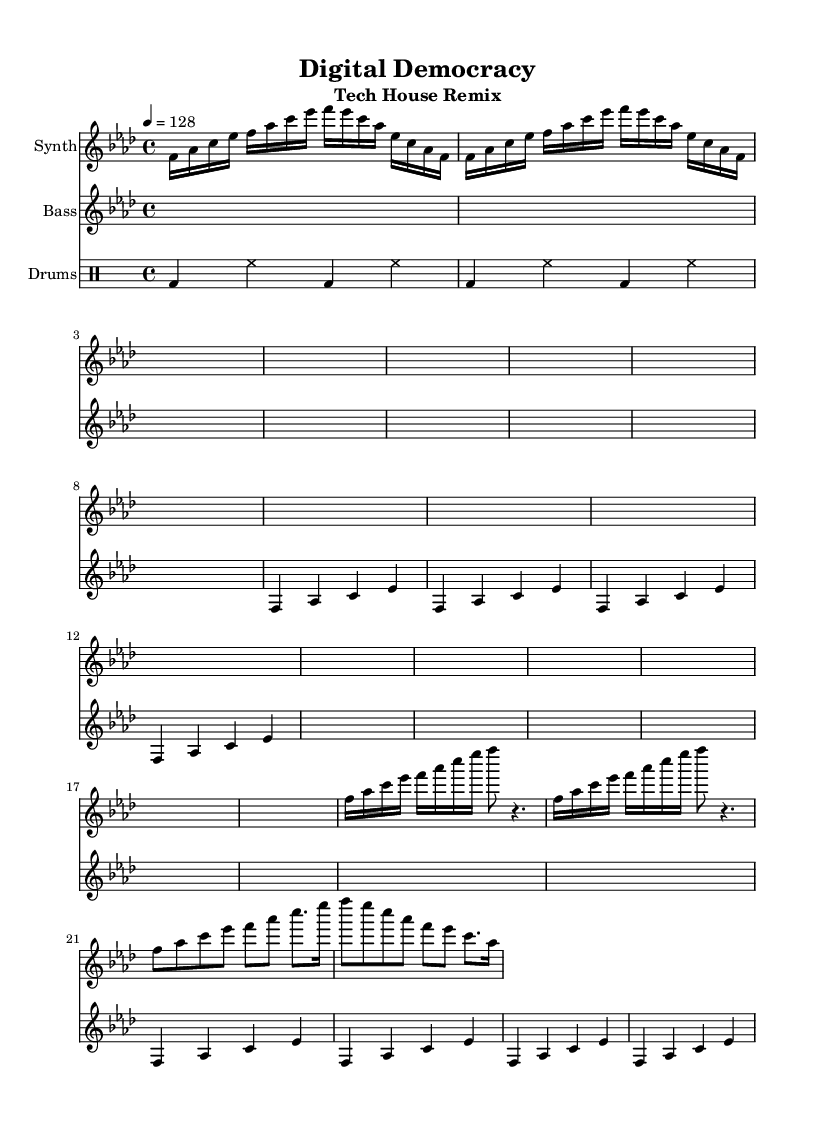What is the key signature of this music? The key signature is F minor, which is indicated by four flats (B♭, E♭, A♭, and D♭). This information is derived from the key signature notation at the beginning of the score.
Answer: F minor What is the time signature of this music? The time signature is 4/4, which is noted at the beginning of the score. This means there are four beats in a measure, and the quarter note gets one beat.
Answer: 4/4 What is the tempo marking of this piece? The tempo marking is 128 beats per minute, indicated by the "4 = 128" notation in the header. This shows how many beats occur in a minute.
Answer: 128 How many times is the bass verse repeated? The bass verse is repeated four times as noted by the "repeat unfold 4" instruction in the score for the bass part.
Answer: 4 What type of drum is primarily used in the pattern? The primary drum used in the pattern is the bass drum, as indicated by the "bd" notation in the drum pattern section of the score.
Answer: Bass drum How many measures are included in the synth intro section? The synth intro section consists of two measures, as indicated by the "repeat unfold 2" instruction which signifies that the musical material repeats for two full measures.
Answer: 2 What is the main style of this remix? The main style of this remix is Tech House, which is evident from the syncopated rhythms, steady beats, and electronic sound typical of this genre.
Answer: Tech House 